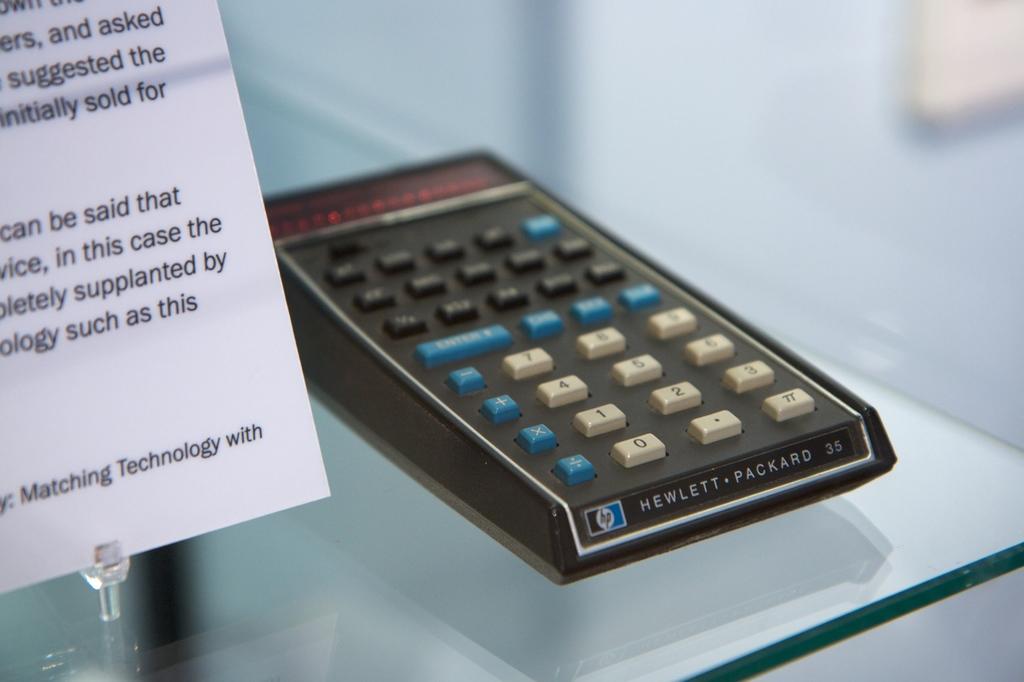Who created this?
Ensure brevity in your answer.  Hewlett-packard. 